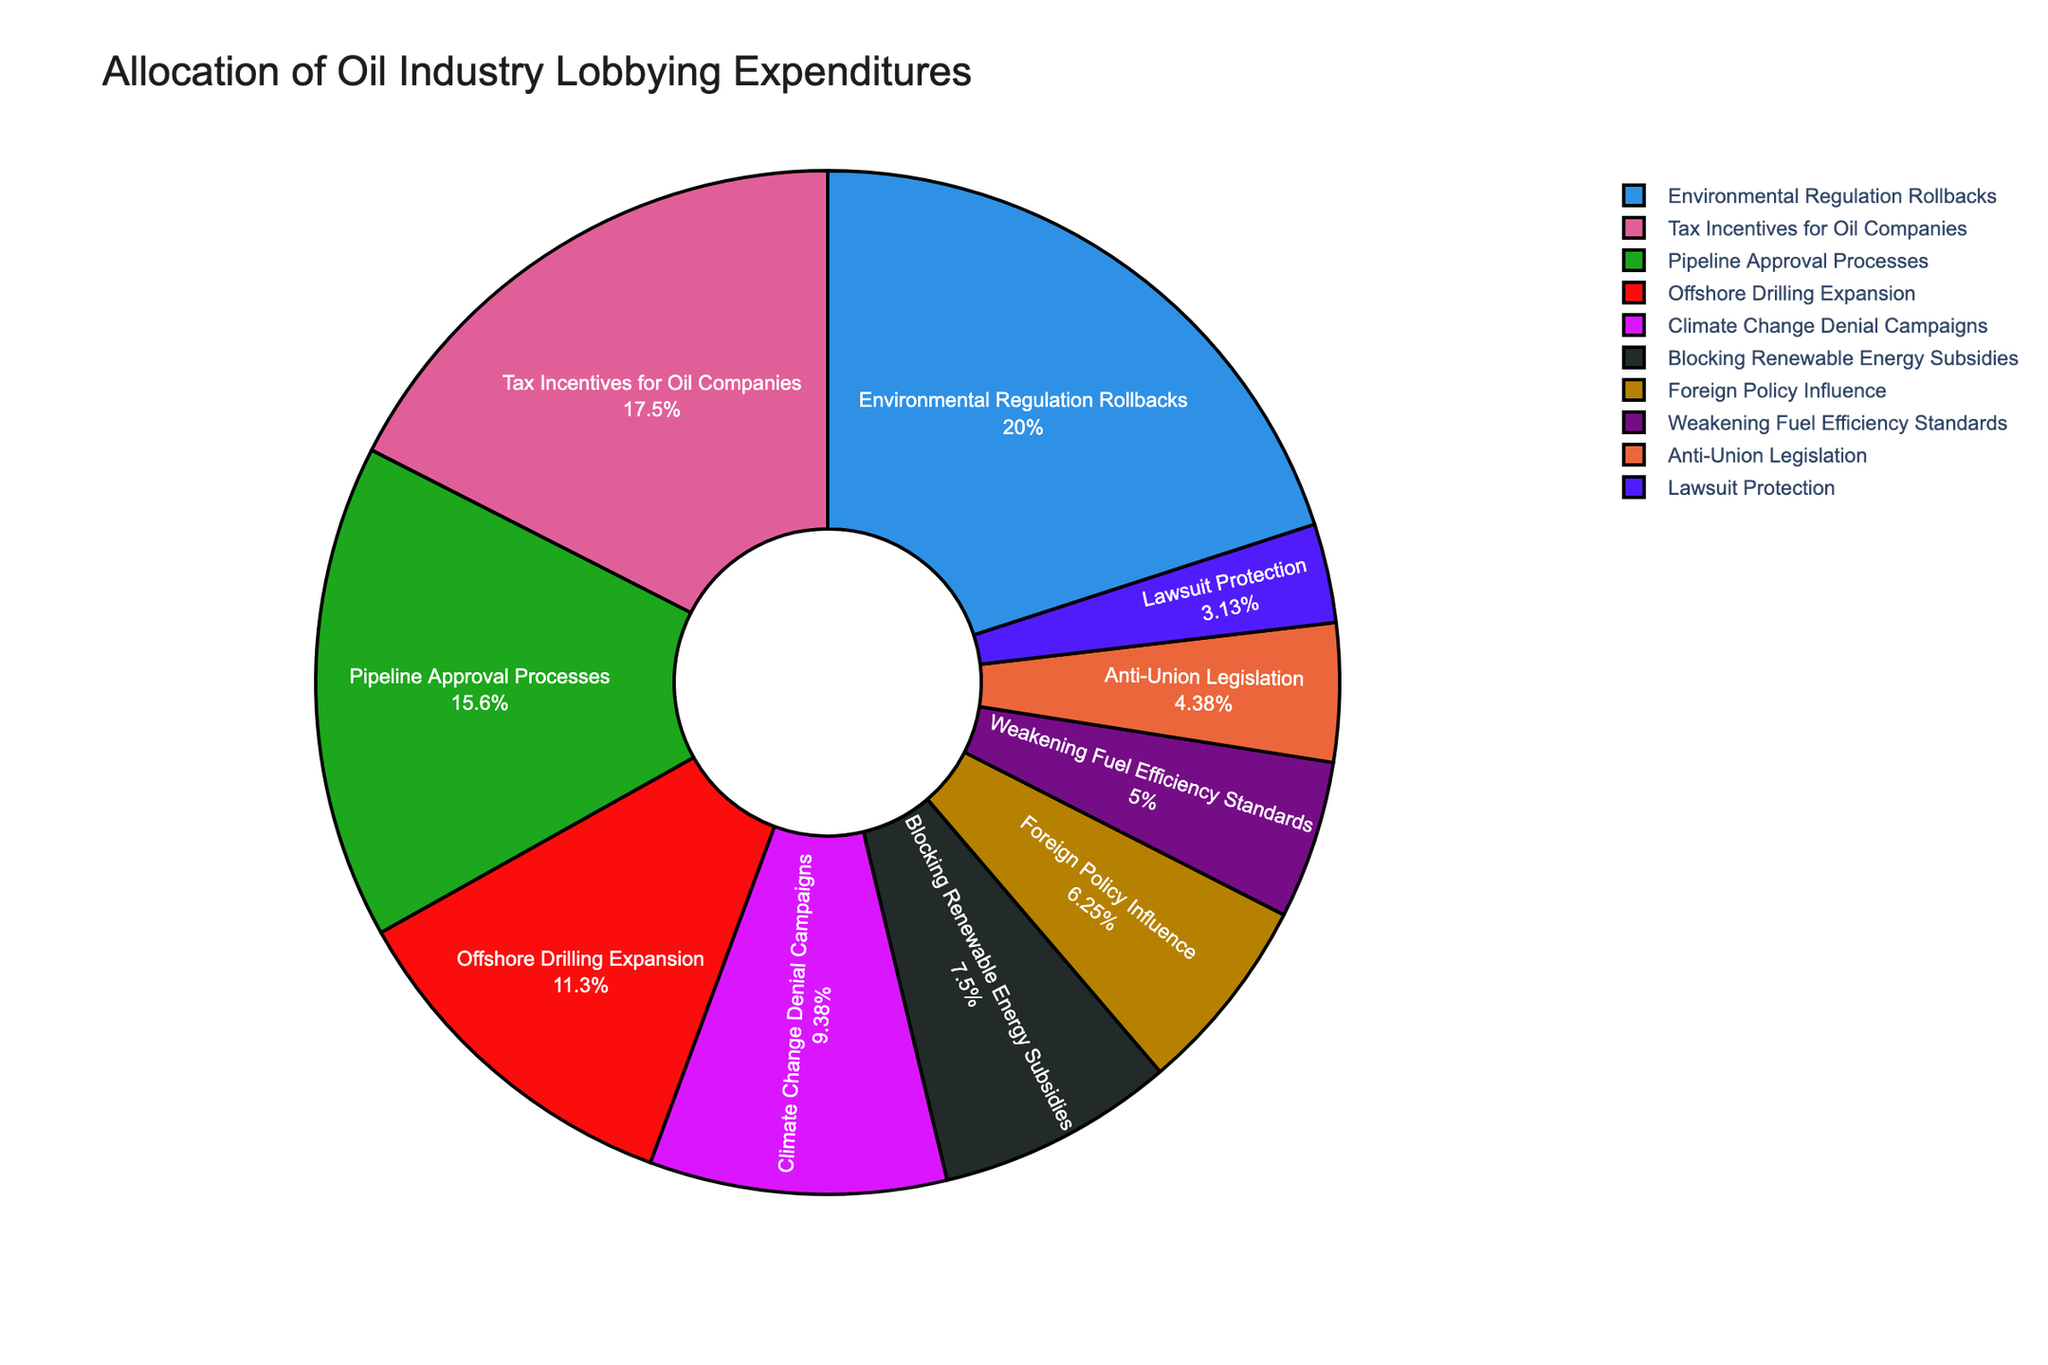What issue received the highest allocation of lobbying expenditures? The slice in the pie chart labeled "Environmental Regulation Rollbacks" is the largest.
Answer: Environmental Regulation Rollbacks How much more was spent on Environmental Regulation Rollbacks than on Offshore Drilling Expansion? The figure shows $32,000,000 for Environmental Regulation Rollbacks and $18,000,000 for Offshore Drilling Expansion. The difference is $32,000,000 - $18,000,000.
Answer: $14,000,000 What is the combined expenditure on Pipeline Approval Processes and Climate Change Denial Campaigns? From the pie chart, the expenditure on Pipeline Approval Processes is $25,000,000 and on Climate Change Denial Campaigns is $15,000,000. Adding these amounts gives $25,000,000 + $15,000,000.
Answer: $40,000,000 Which issue had the smallest allocation of lobbying expenditures? The smallest slice on the pie chart belongs to "Lawsuit Protection".
Answer: Lawsuit Protection Is the expenditure on Tax Incentives for Oil Companies greater than, less than, or equal to the expenditure on Blocking Renewable Energy Subsidies? The pie chart shows $28,000,000 for Tax Incentives for Oil Companies and $12,000,000 for Blocking Renewable Energy Subsidies. $28,000,000 is greater than $12,000,000.
Answer: Greater than How does the expenditure on Weakening Fuel Efficiency Standards compare to that on Anti-Union Legislation? According to the chart, the expenditure on Weakening Fuel Efficiency Standards is $8,000,000 and on Anti-Union Legislation is $7,000,000. $8,000,000 is greater than $7,000,000.
Answer: Greater than What percentage of the total lobbying expenditure was allocated to Foreign Policy Influence? The expenditure for Foreign Policy Influence is $10,000,000. To find the percentage, we calculate ($10,000,000 / Total expenditure) * 100. The total expenditure is the sum of all provided values ($32,000,000 + $28,000,000 + $25,000,000 + $18,000,000 + $15,000,000 + $12,000,000 + $10,000,000 + $8,000,000 + $7,000,000 + $5,000,000 = $160,000,000). Thus, ($10,000,000 / $160,000,000) * 100 = 6.25%.
Answer: 6.25% What is the combined expenditure on issues directly opposing environmental regulations (Environmental Regulation Rollbacks, Climate Change Denial Campaigns, and Blocking Renewable Energy Subsidies)? Adding the expenditures for these issues: $32,000,000 (Environmental Regulation Rollbacks) + $15,000,000 (Climate Change Denial Campaigns) + $12,000,000 (Blocking Renewable Energy Subsidies) = $59,000,000.
Answer: $59,000,000 Which two issues have the closest expenditures, and what are their amounts? By comparing the slices, "Weakening Fuel Efficiency Standards" ($8,000,000) and "Anti-Union Legislation" ($7,000,000) are closest in value.
Answer: Weakening Fuel Efficiency Standards and Anti-Union Legislation, $8,000,000 and $7,000,000 